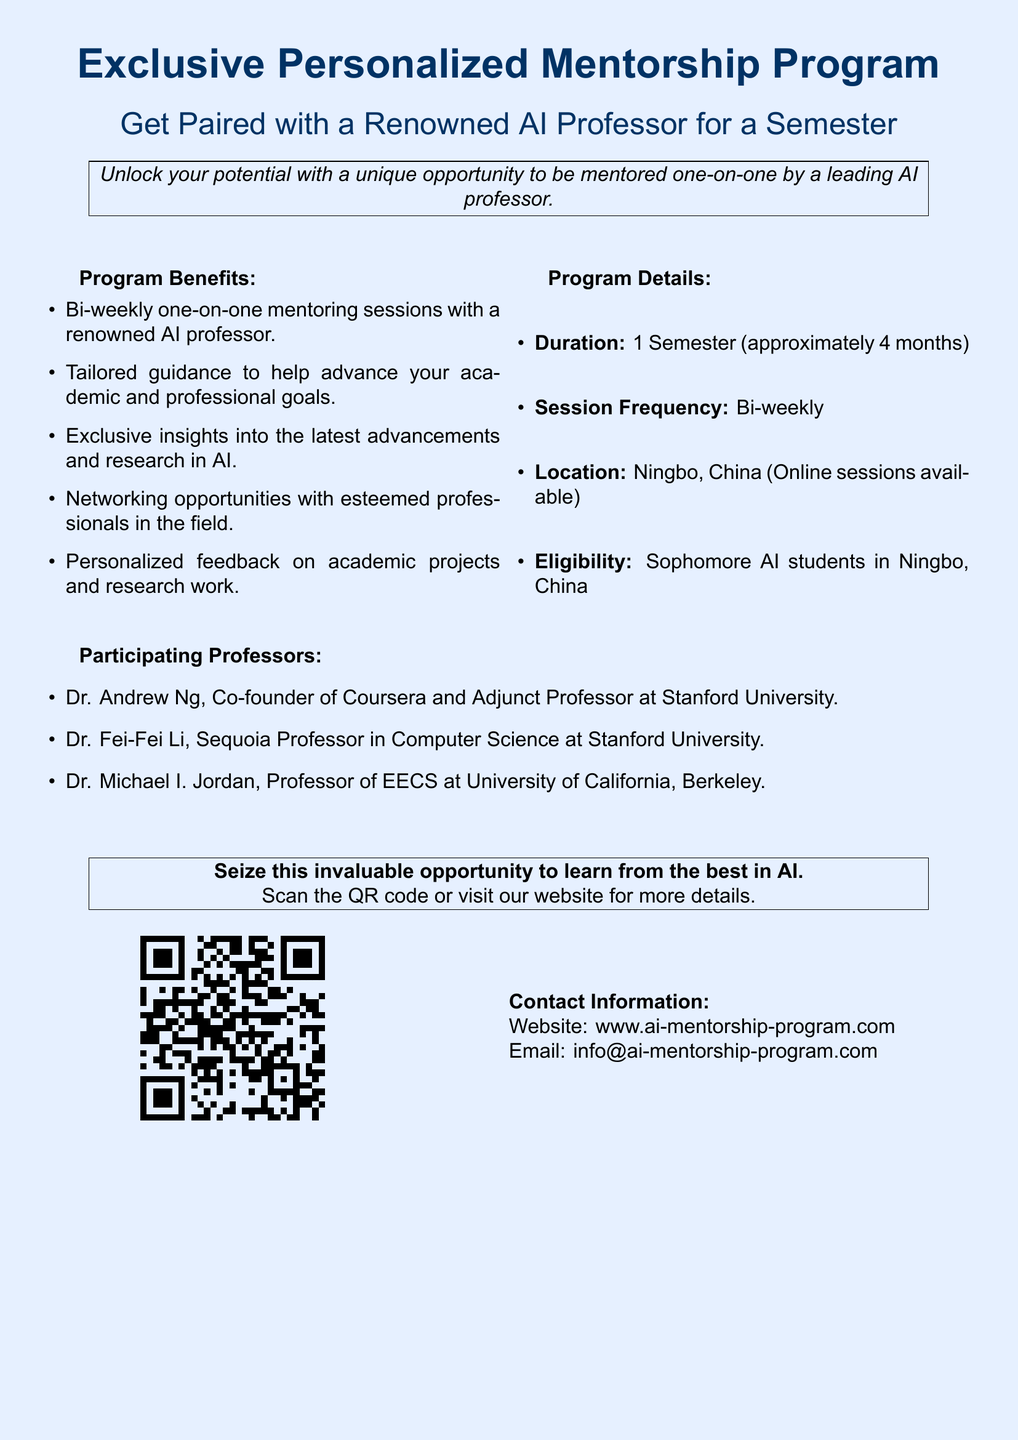What is the duration of the program? The duration of the program is mentioned in the document, which states it lasts for approximately 4 months.
Answer: 1 Semester (approximately 4 months) How often are the mentoring sessions held? The document specifies that the mentoring sessions occur bi-weekly.
Answer: Bi-weekly Who are some of the participating professors? The document lists several renowned AI professors participating in the program, including Dr. Andrew Ng.
Answer: Dr. Andrew Ng, Dr. Fei-Fei Li, Dr. Michael I. Jordan Where are the mentoring sessions located? The document notes that the sessions take place in Ningbo, China, with online options available.
Answer: Ningbo, China (Online sessions available) What type of feedback can participants expect? The document states that participants will receive personalized feedback on their academic projects and research work.
Answer: Personalized feedback on academic projects and research work What is the eligibility requirement for the program? The eligibility criteria for this program are detailed in the document, which specifies sophomore AI students.
Answer: Sophomore AI students in Ningbo, China What is the main theme of the program? The program is focused on personalized mentorship in AI, as described in the introductory statement.
Answer: Personalized Mentorship Program What kind of opportunities does the program provide? The document outlines several opportunities, including networking with esteemed professionals in the field.
Answer: Networking opportunities with esteemed professionals in the field 